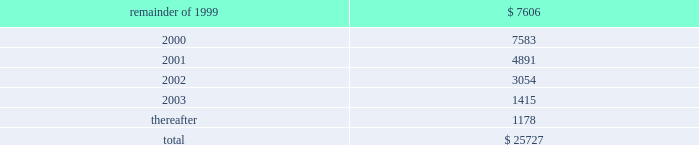The containerboard group ( a division of tenneco packaging inc. ) notes to combined financial statements ( continued ) april 11 , 1999 14 .
Leases ( continued ) to the sale transaction on april 12 , 1999 .
Therefore , the remaining outstanding aggregate minimum rental commitments under noncancelable operating leases are as follows : ( in thousands ) .
15 .
Sale of assets in the second quarter of 1996 , packaging entered into an agreement to form a joint venture with caraustar industries whereby packaging sold its two recycled paperboard mills and a fiber recycling operation and brokerage business to the joint venture in return for cash and a 20% ( 20 % ) equity interest in the joint venture .
Proceeds from the sale were approximately $ 115 million and the group recognized a $ 50 million pretax gain ( $ 30 million after taxes ) in the second quarter of 1996 .
In june , 1998 , packaging sold its remaining 20% ( 20 % ) equity interest in the joint venture to caraustar industries for cash and a note of $ 26000000 .
The group recognized a $ 15 million pretax gain on this transaction .
At april 11 , 1999 , the balance of the note with accrued interest is $ 27122000 .
The note was paid in june , 1999 .
16 .
Subsequent events on august 25 , 1999 , pca and packaging agreed that the acquisition consideration should be reduced as a result of a postclosing price adjustment by an amount equal to $ 20 million plus interest through the date of payment by packaging .
The group recorded $ 11.9 million of this amount as part of the impairment charge on the accompanying financial statements , representing the amount that was previously estimated by packaging .
Pca intends to record the remaining amount in september , 1999 .
In august , 1999 , pca signed purchase and sales agreements with various buyers to sell approximately 405000 acres of timberland .
Pca has completed the sale of approximately 260000 of these acres and expects to complete the sale of the remaining acres by mid-november , 1999. .
Of the post-closing price adjustment of $ 20 million plus interest , what percentage was recognized as part of the impairment charge on the accompanying financial statements? 
Computations: (11.9 / 20)
Answer: 0.595. 